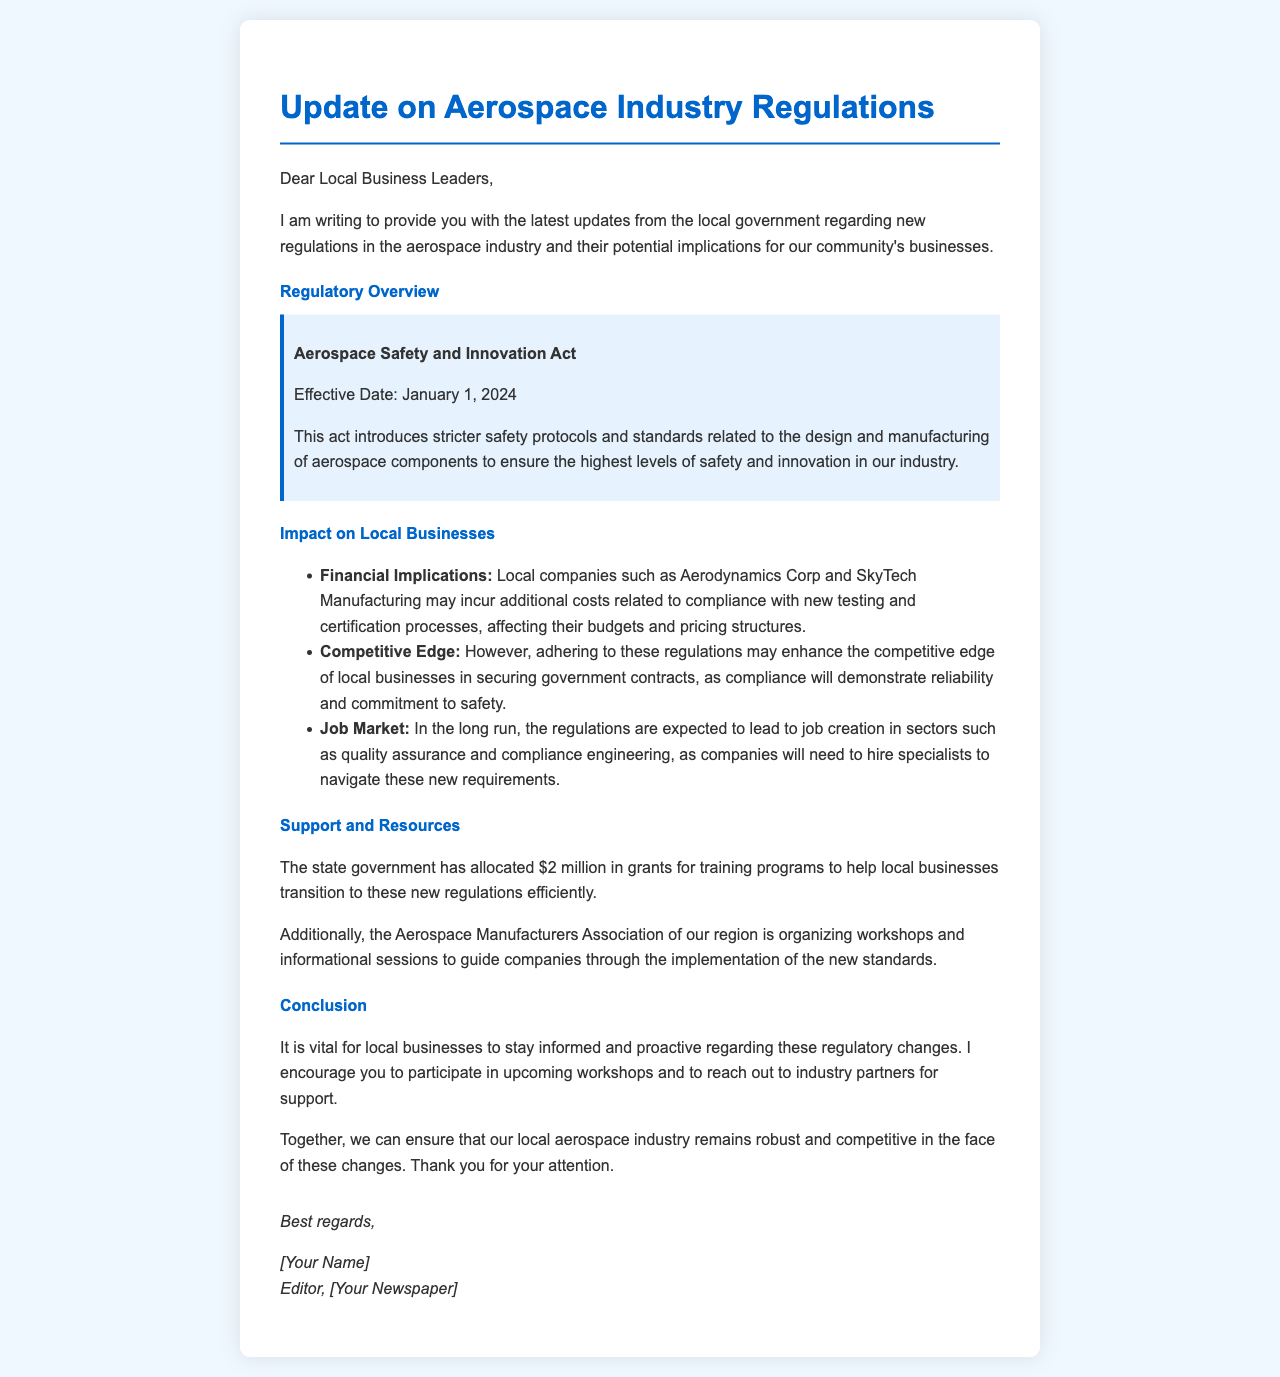what is the effective date of the Aerospace Safety and Innovation Act? The effective date is explicitly stated in the document, which is January 1, 2024.
Answer: January 1, 2024 what are the allocated funds for training programs? The document mentions the allocation made by the state government specifically for training programs, which is $2 million.
Answer: $2 million which local company is mentioned in relation to financial implications? The document lists local companies affected by the new regulations, specifically mentioning Aerodynamics Corp.
Answer: Aerodynamics Corp what is one expected outcome on the job market due to the regulations? The document describes a long-term outcome of job creation, particularly in sectors like quality assurance and compliance engineering.
Answer: job creation what organization is mentioned as organizing workshops for local businesses? The document states that the Aerospace Manufacturers Association is involved in organizing workshops and informational sessions.
Answer: Aerospace Manufacturers Association how might compliance to the new regulations affect competitive edge? The document suggests that compliance may enhance competitive edge in securing government contracts, highlighting its importance for local businesses.
Answer: enhance competitive edge what is the main intention of the letter? The primary purpose of the letter is to inform local business leaders about new aerospace regulations and their implications.
Answer: inform local business leaders how are local businesses encouraged to engage with the new regulations? The document suggests that local businesses are encouraged to participate in upcoming workshops for support and guidance.
Answer: participate in upcoming workshops 